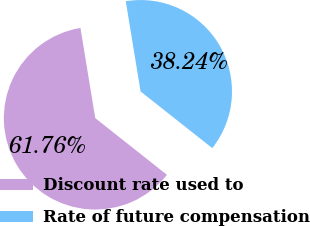Convert chart to OTSL. <chart><loc_0><loc_0><loc_500><loc_500><pie_chart><fcel>Discount rate used to<fcel>Rate of future compensation<nl><fcel>61.76%<fcel>38.24%<nl></chart> 